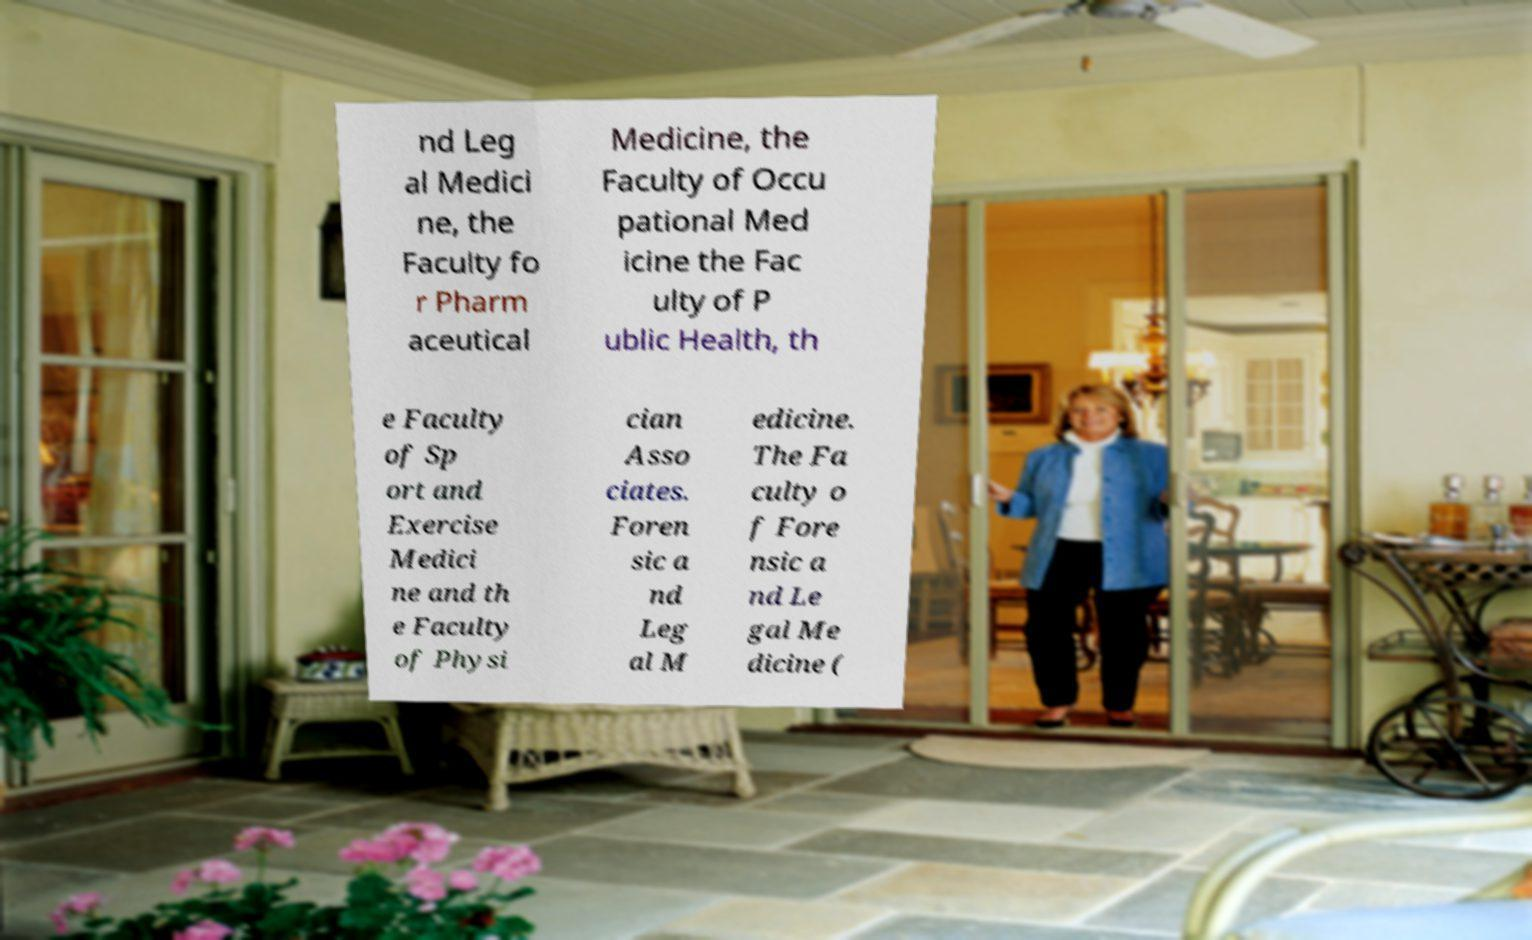Please identify and transcribe the text found in this image. nd Leg al Medici ne, the Faculty fo r Pharm aceutical Medicine, the Faculty of Occu pational Med icine the Fac ulty of P ublic Health, th e Faculty of Sp ort and Exercise Medici ne and th e Faculty of Physi cian Asso ciates. Foren sic a nd Leg al M edicine. The Fa culty o f Fore nsic a nd Le gal Me dicine ( 